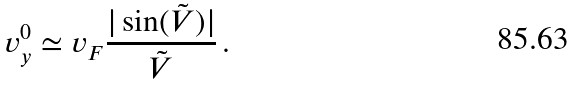<formula> <loc_0><loc_0><loc_500><loc_500>v _ { y } ^ { 0 } \simeq v _ { F } \frac { | \sin ( \tilde { V } ) | } { \tilde { V } } \, .</formula> 